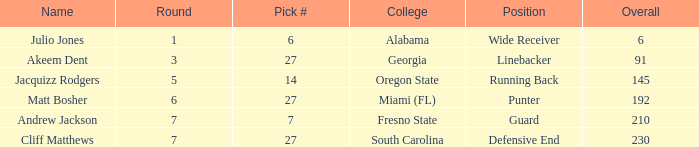Write the full table. {'header': ['Name', 'Round', 'Pick #', 'College', 'Position', 'Overall'], 'rows': [['Julio Jones', '1', '6', 'Alabama', 'Wide Receiver', '6'], ['Akeem Dent', '3', '27', 'Georgia', 'Linebacker', '91'], ['Jacquizz Rodgers', '5', '14', 'Oregon State', 'Running Back', '145'], ['Matt Bosher', '6', '27', 'Miami (FL)', 'Punter', '192'], ['Andrew Jackson', '7', '7', 'Fresno State', 'Guard', '210'], ['Cliff Matthews', '7', '27', 'South Carolina', 'Defensive End', '230']]} Which highest pick number had Akeem Dent as a name and where the overall was less than 91? None. 